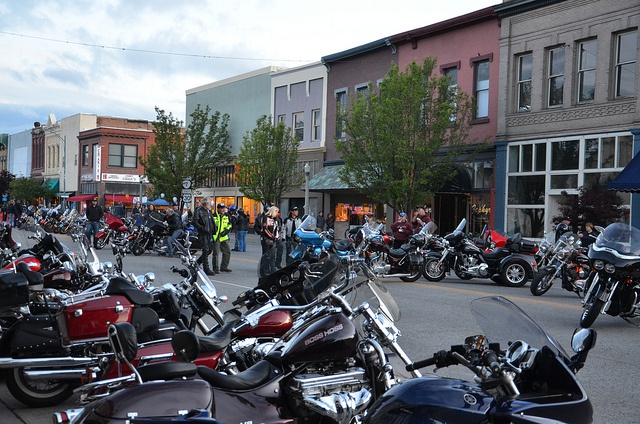Describe the objects in this image and their specific colors. I can see motorcycle in lightblue, black, gray, darkgray, and white tones, motorcycle in lightblue, black, gray, and maroon tones, motorcycle in lightblue, black, gray, and navy tones, motorcycle in lightblue, black, gray, darkgray, and navy tones, and motorcycle in lightblue, black, gray, and navy tones in this image. 